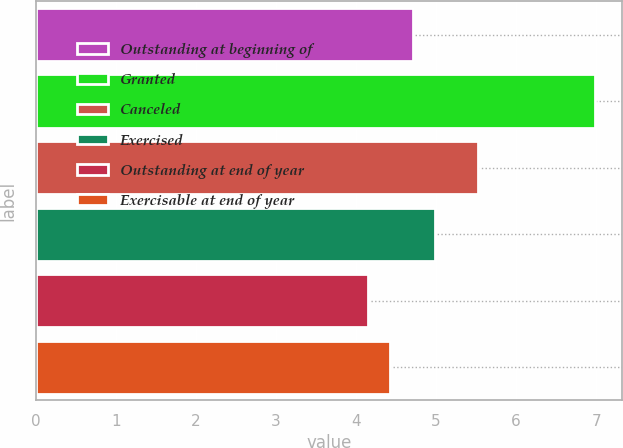Convert chart. <chart><loc_0><loc_0><loc_500><loc_500><bar_chart><fcel>Outstanding at beginning of<fcel>Granted<fcel>Canceled<fcel>Exercised<fcel>Outstanding at end of year<fcel>Exercisable at end of year<nl><fcel>4.71<fcel>6.98<fcel>5.53<fcel>4.99<fcel>4.15<fcel>4.43<nl></chart> 